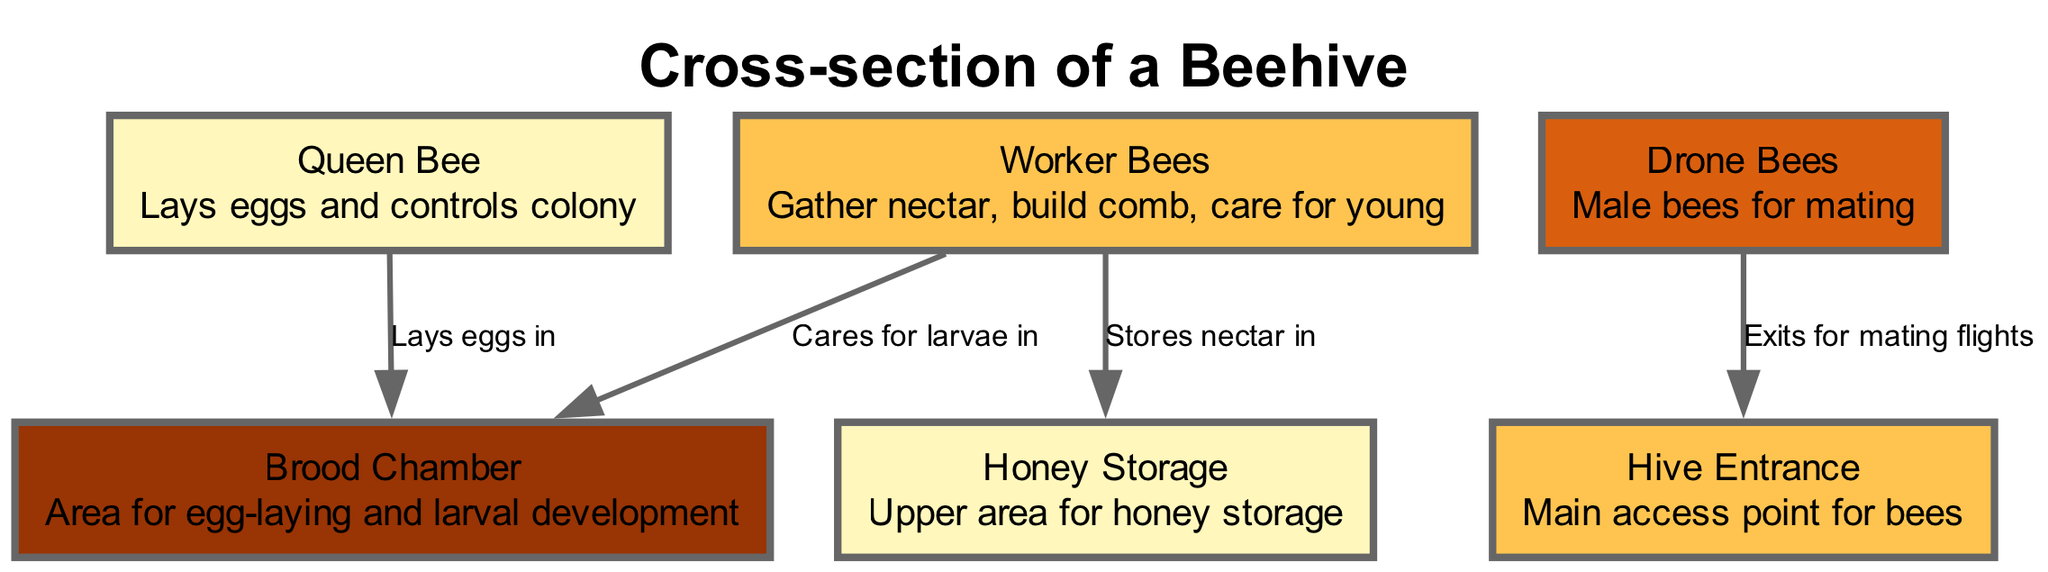What is the main role of the Queen Bee? The diagram states that the Queen Bee "Lays eggs and controls colony," which indicates that her primary role is to reproduce and maintain the colony's order.
Answer: Lays eggs and controls colony How many different castes are shown in the diagram? The diagram features three distinct castes: Queen Bee, Worker Bees, and Drone Bees. Each caste has its own unique role within the hive.
Answer: Three Which caste is responsible for caring for larvae? The diagram specifies that Worker Bees "Cares for larvae in" the Brood Chamber, indicating that they are the ones responsible for nurturing the young bees.
Answer: Worker Bees Where does the Queen Bee lay her eggs? The diagram connects the Queen Bee to the Brood Chamber with the label "Lays eggs in," indicating that this is the designated area for her egg-laying activities.
Answer: Brood Chamber What does the Honey Storage area contain? The diagram describes the Honey Storage as the "Upper area for honey storage," confirming that this space is dedicated to storing honey gathered by the Worker Bees.
Answer: Honey Which caste exits the hive for mating flights? The diagram shows that Drone Bees "Exits for mating flights" at the Hive Entrance, indicating that they leave the hive specifically for mating purposes.
Answer: Drone Bees What is the function of the Hive Entrance? The diagram labels the Hive Entrance as "Main access point for bees," which indicates that it serves as the primary entry and exit point for the bees to enter and exit the hive.
Answer: Main access point for bees How do Worker Bees contribute to honey storage? The Worker Bees are noted in the diagram as gathering nectar, which aligns with their function of storing it in the Honey Storage area, thus directly contributing to honey production.
Answer: Stores nectar in Honey Storage What is the relationship between Worker Bees and the Brood Chamber? The diagram shows a connection from Worker Bees to the Brood Chamber, labeled "Cares for larvae in," indicating that they have a nurturing role in that specific area.
Answer: Cares for larvae in Brood Chamber 